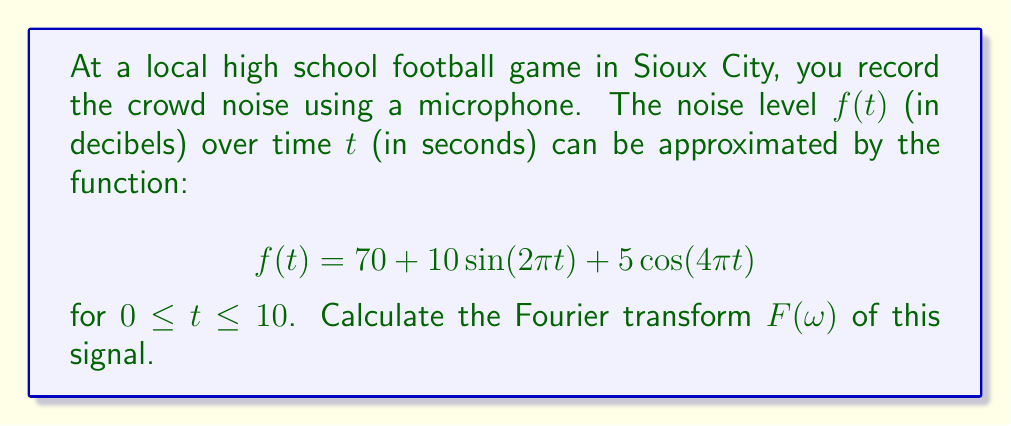Teach me how to tackle this problem. Let's approach this step-by-step:

1) The Fourier transform of a function $f(t)$ is given by:

   $$F(\omega) = \int_{-\infty}^{\infty} f(t) e^{-i\omega t} dt$$

2) In our case, $f(t)$ is defined only for $0 \leq t \leq 10$, so we'll integrate from 0 to 10:

   $$F(\omega) = \int_{0}^{10} (70 + 10\sin(2\pi t) + 5\cos(4\pi t)) e^{-i\omega t} dt$$

3) We can split this into three integrals:

   $$F(\omega) = 70\int_{0}^{10} e^{-i\omega t} dt + 10\int_{0}^{10} \sin(2\pi t)e^{-i\omega t} dt + 5\int_{0}^{10} \cos(4\pi t)e^{-i\omega t} dt$$

4) For the first integral:
   
   $$70\int_{0}^{10} e^{-i\omega t} dt = 70 \left[-\frac{1}{i\omega}e^{-i\omega t}\right]_{0}^{10} = \frac{70}{i\omega}(1-e^{-10i\omega})$$

5) For the second and third integrals, we can use the identity:
   
   $$\sin(at) = \frac{e^{iat} - e^{-iat}}{2i}, \cos(at) = \frac{e^{iat} + e^{-iat}}{2}$$

6) After applying these identities and integrating, we get:

   $$10\int_{0}^{10} \sin(2\pi t)e^{-i\omega t} dt = 5\pi i \left(\frac{1-e^{-10i\omega}}{(\omega+2\pi)(\omega-2\pi)}\right)$$

   $$5\int_{0}^{10} \cos(4\pi t)e^{-i\omega t} dt = \frac{5}{2} \left(\frac{1-e^{-10i\omega}}{\omega+4\pi} + \frac{1-e^{-10i\omega}}{\omega-4\pi}\right)$$

7) Combining all terms, we get the final Fourier transform:

   $$F(\omega) = \frac{70}{i\omega}(1-e^{-10i\omega}) + 5\pi i \left(\frac{1-e^{-10i\omega}}{(\omega+2\pi)(\omega-2\pi)}\right) + \frac{5}{2} \left(\frac{1-e^{-10i\omega}}{\omega+4\pi} + \frac{1-e^{-10i\omega}}{\omega-4\pi}\right)$$
Answer: $$F(\omega) = \frac{70}{i\omega}(1-e^{-10i\omega}) + 5\pi i \left(\frac{1-e^{-10i\omega}}{(\omega+2\pi)(\omega-2\pi)}\right) + \frac{5}{2} \left(\frac{1-e^{-10i\omega}}{\omega+4\pi} + \frac{1-e^{-10i\omega}}{\omega-4\pi}\right)$$ 